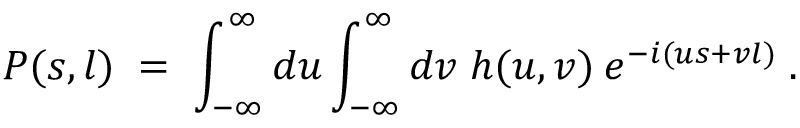<formula> <loc_0><loc_0><loc_500><loc_500>P ( s , l ) \, = \, \int _ { - \infty } ^ { \infty } d u \int _ { - \infty } ^ { \infty } d v \, h ( u , v ) \, e ^ { - i ( u s + v l ) } \, .</formula> 